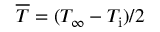<formula> <loc_0><loc_0><loc_500><loc_500>{ \overline { T } } = ( T _ { \infty } - T _ { i } ) / 2</formula> 